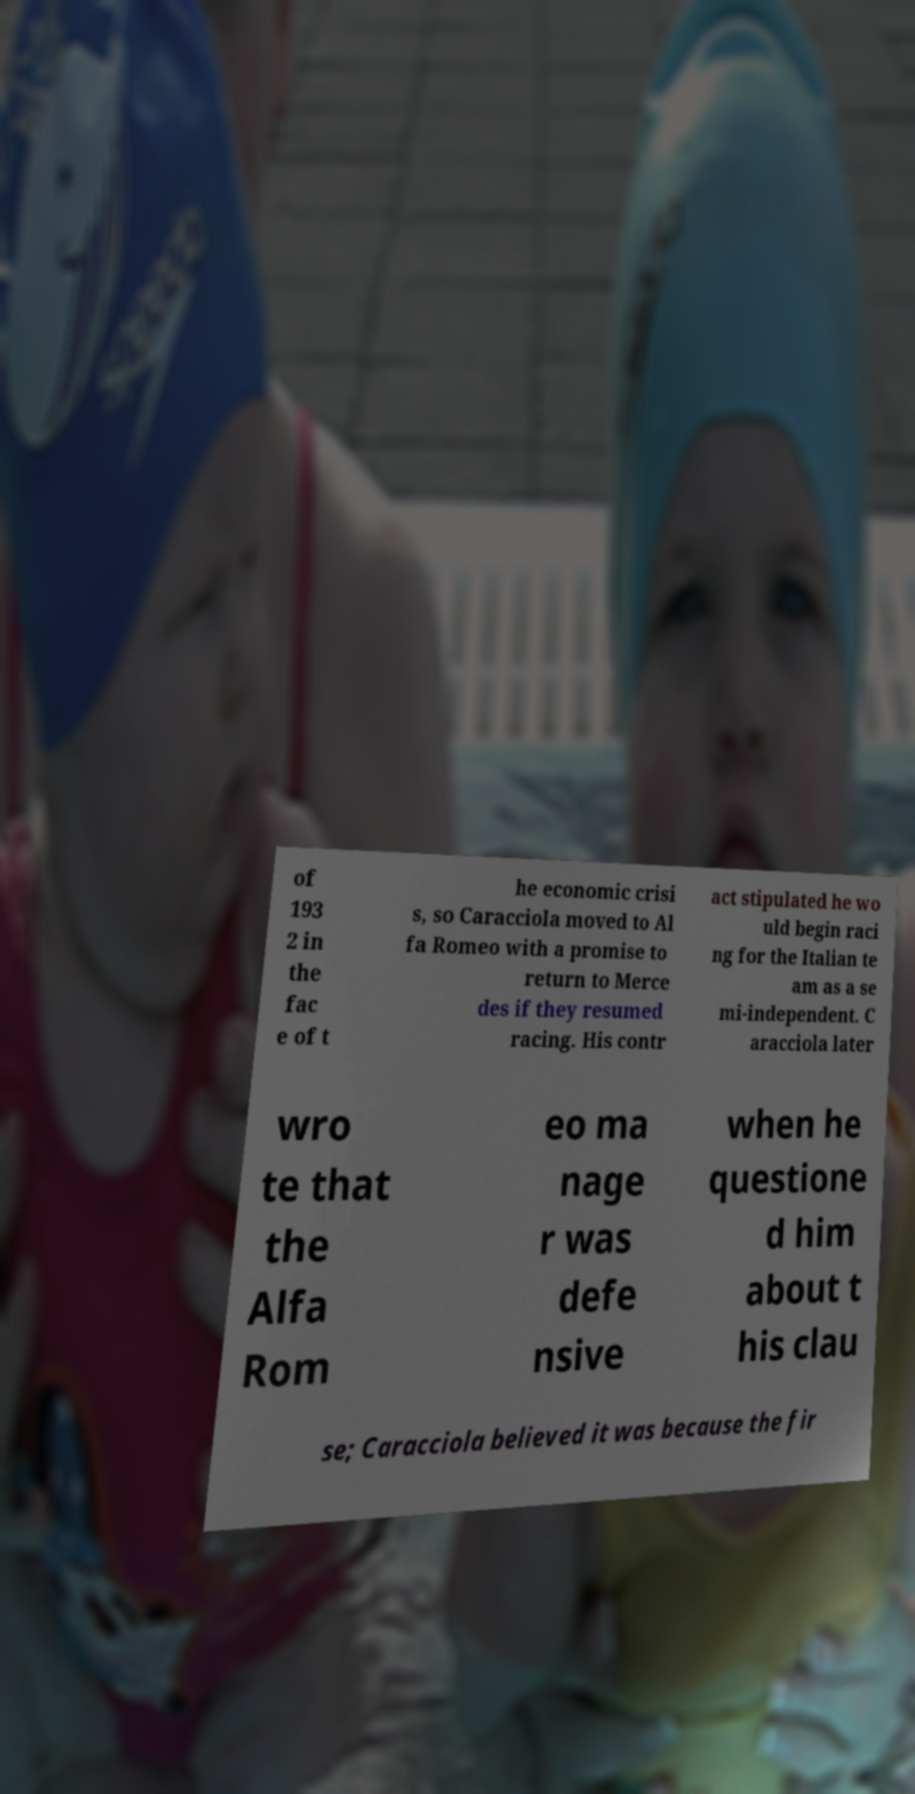There's text embedded in this image that I need extracted. Can you transcribe it verbatim? of 193 2 in the fac e of t he economic crisi s, so Caracciola moved to Al fa Romeo with a promise to return to Merce des if they resumed racing. His contr act stipulated he wo uld begin raci ng for the Italian te am as a se mi-independent. C aracciola later wro te that the Alfa Rom eo ma nage r was defe nsive when he questione d him about t his clau se; Caracciola believed it was because the fir 